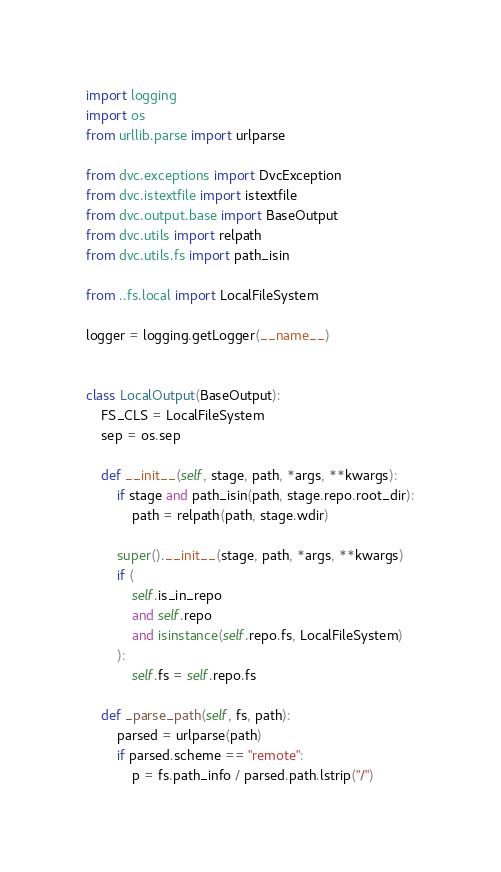<code> <loc_0><loc_0><loc_500><loc_500><_Python_>import logging
import os
from urllib.parse import urlparse

from dvc.exceptions import DvcException
from dvc.istextfile import istextfile
from dvc.output.base import BaseOutput
from dvc.utils import relpath
from dvc.utils.fs import path_isin

from ..fs.local import LocalFileSystem

logger = logging.getLogger(__name__)


class LocalOutput(BaseOutput):
    FS_CLS = LocalFileSystem
    sep = os.sep

    def __init__(self, stage, path, *args, **kwargs):
        if stage and path_isin(path, stage.repo.root_dir):
            path = relpath(path, stage.wdir)

        super().__init__(stage, path, *args, **kwargs)
        if (
            self.is_in_repo
            and self.repo
            and isinstance(self.repo.fs, LocalFileSystem)
        ):
            self.fs = self.repo.fs

    def _parse_path(self, fs, path):
        parsed = urlparse(path)
        if parsed.scheme == "remote":
            p = fs.path_info / parsed.path.lstrip("/")</code> 